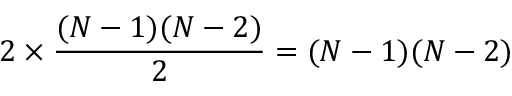Convert formula to latex. <formula><loc_0><loc_0><loc_500><loc_500>2 \times \frac { ( N - 1 ) ( N - 2 ) } { 2 } = ( N - 1 ) ( N - 2 )</formula> 